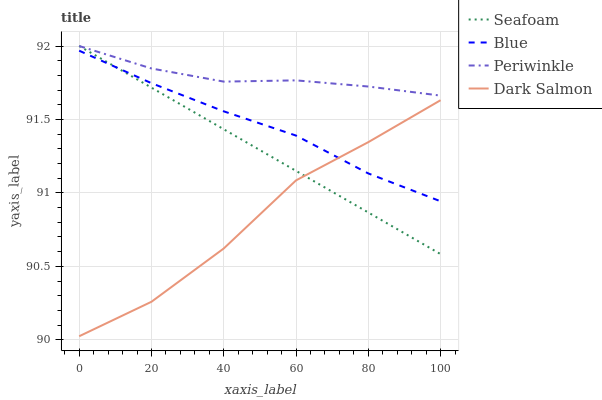Does Dark Salmon have the minimum area under the curve?
Answer yes or no. Yes. Does Periwinkle have the maximum area under the curve?
Answer yes or no. Yes. Does Seafoam have the minimum area under the curve?
Answer yes or no. No. Does Seafoam have the maximum area under the curve?
Answer yes or no. No. Is Seafoam the smoothest?
Answer yes or no. Yes. Is Dark Salmon the roughest?
Answer yes or no. Yes. Is Periwinkle the smoothest?
Answer yes or no. No. Is Periwinkle the roughest?
Answer yes or no. No. Does Dark Salmon have the lowest value?
Answer yes or no. Yes. Does Seafoam have the lowest value?
Answer yes or no. No. Does Seafoam have the highest value?
Answer yes or no. Yes. Does Dark Salmon have the highest value?
Answer yes or no. No. Is Dark Salmon less than Periwinkle?
Answer yes or no. Yes. Is Periwinkle greater than Dark Salmon?
Answer yes or no. Yes. Does Seafoam intersect Dark Salmon?
Answer yes or no. Yes. Is Seafoam less than Dark Salmon?
Answer yes or no. No. Is Seafoam greater than Dark Salmon?
Answer yes or no. No. Does Dark Salmon intersect Periwinkle?
Answer yes or no. No. 